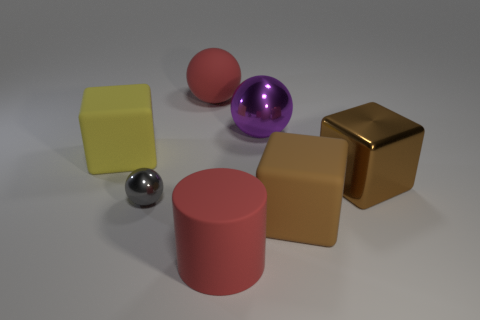Are the large thing on the left side of the red matte ball and the brown object in front of the gray metallic object made of the same material?
Your response must be concise. Yes. Are there more brown shiny things that are behind the purple ball than large yellow rubber objects in front of the small metal thing?
Keep it short and to the point. No. What material is the big thing that is the same color as the big cylinder?
Ensure brevity in your answer.  Rubber. Is there any other thing that is the same shape as the purple object?
Give a very brief answer. Yes. There is a large object that is both left of the big red matte cylinder and in front of the large red rubber ball; what material is it?
Keep it short and to the point. Rubber. Does the gray sphere have the same material as the red object that is to the left of the big cylinder?
Keep it short and to the point. No. Is there anything else that is the same size as the cylinder?
Keep it short and to the point. Yes. How many things are brown blocks or objects right of the red cylinder?
Your answer should be very brief. 3. There is a matte thing that is behind the yellow cube; is it the same size as the shiny thing that is left of the big matte ball?
Your answer should be very brief. No. What number of other objects are there of the same color as the rubber ball?
Your answer should be very brief. 1. 